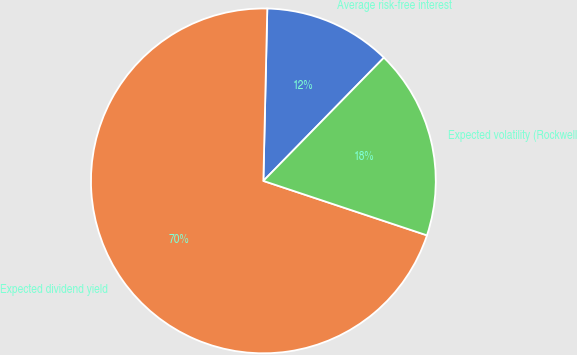Convert chart to OTSL. <chart><loc_0><loc_0><loc_500><loc_500><pie_chart><fcel>Average risk-free interest<fcel>Expected dividend yield<fcel>Expected volatility (Rockwell<nl><fcel>11.96%<fcel>70.25%<fcel>17.79%<nl></chart> 